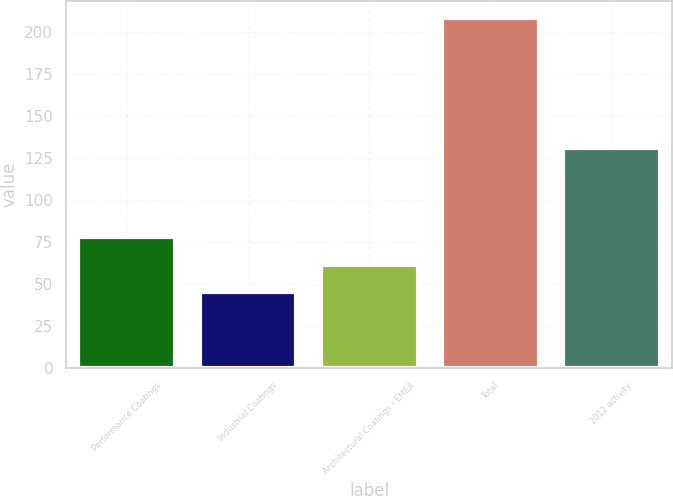<chart> <loc_0><loc_0><loc_500><loc_500><bar_chart><fcel>Performance Coatings<fcel>Industrial Coatings<fcel>Architectural Coatings - EMEA<fcel>Total<fcel>2012 activity<nl><fcel>77.6<fcel>45<fcel>61.3<fcel>208<fcel>131<nl></chart> 